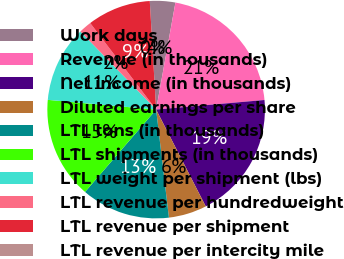Convert chart to OTSL. <chart><loc_0><loc_0><loc_500><loc_500><pie_chart><fcel>Work days<fcel>Revenue (in thousands)<fcel>Net income (in thousands)<fcel>Diluted earnings per share<fcel>LTL tons (in thousands)<fcel>LTL shipments (in thousands)<fcel>LTL weight per shipment (lbs)<fcel>LTL revenue per hundredweight<fcel>LTL revenue per shipment<fcel>LTL revenue per intercity mile<nl><fcel>3.77%<fcel>20.75%<fcel>18.87%<fcel>5.66%<fcel>13.21%<fcel>15.09%<fcel>11.32%<fcel>1.89%<fcel>9.43%<fcel>0.0%<nl></chart> 